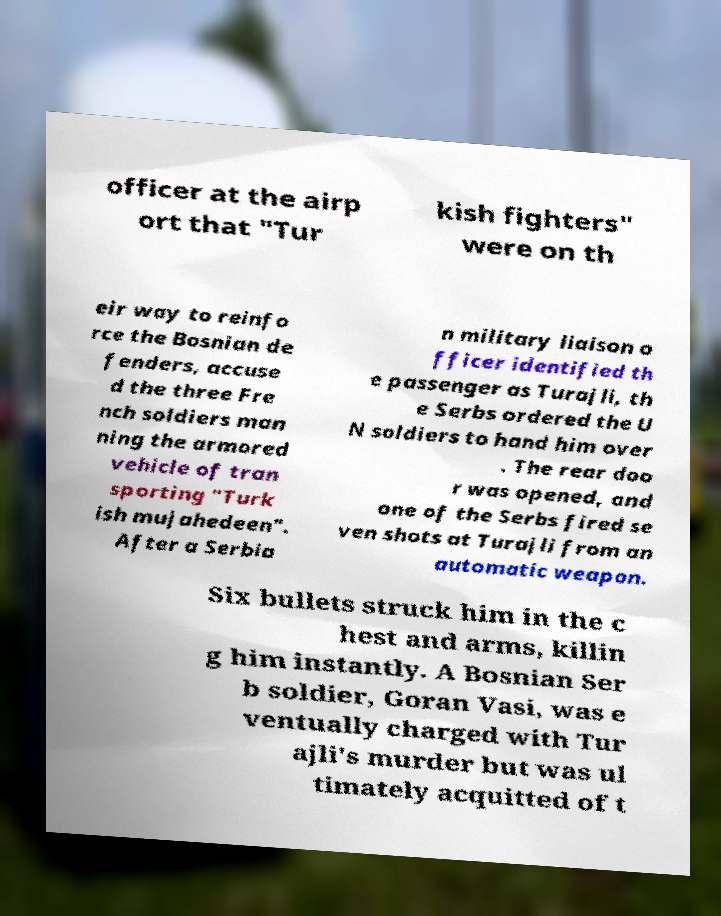Please identify and transcribe the text found in this image. officer at the airp ort that "Tur kish fighters" were on th eir way to reinfo rce the Bosnian de fenders, accuse d the three Fre nch soldiers man ning the armored vehicle of tran sporting "Turk ish mujahedeen". After a Serbia n military liaison o fficer identified th e passenger as Turajli, th e Serbs ordered the U N soldiers to hand him over . The rear doo r was opened, and one of the Serbs fired se ven shots at Turajli from an automatic weapon. Six bullets struck him in the c hest and arms, killin g him instantly. A Bosnian Ser b soldier, Goran Vasi, was e ventually charged with Tur ajli's murder but was ul timately acquitted of t 